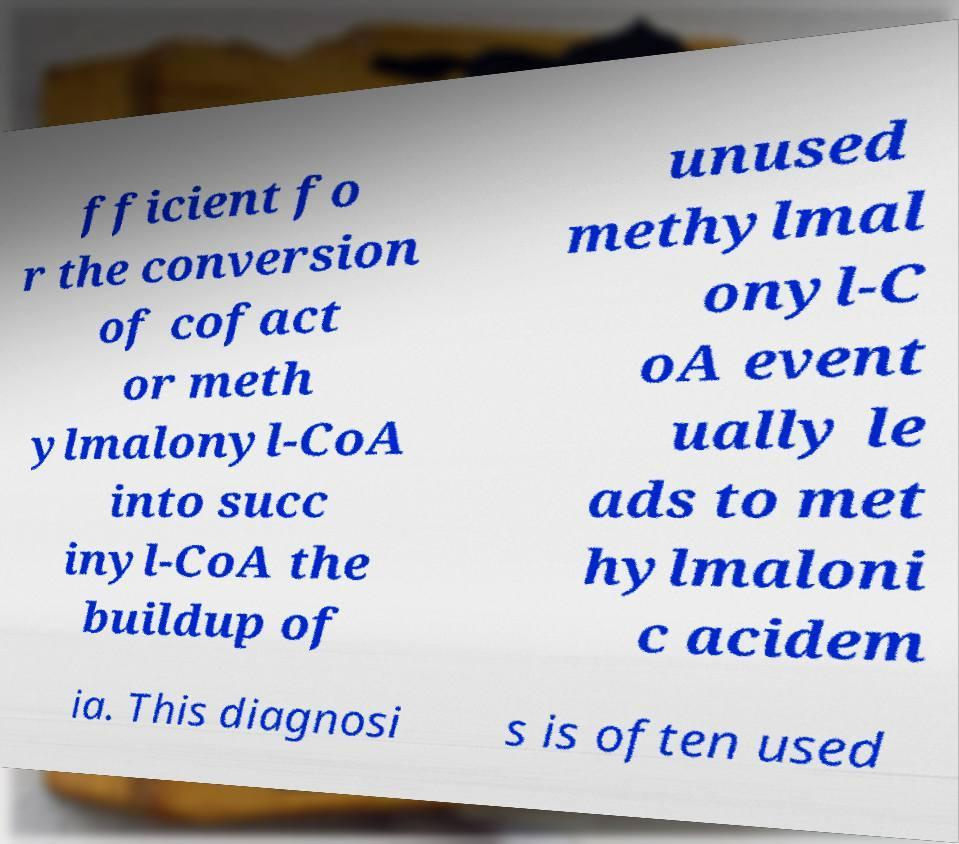For documentation purposes, I need the text within this image transcribed. Could you provide that? fficient fo r the conversion of cofact or meth ylmalonyl-CoA into succ inyl-CoA the buildup of unused methylmal onyl-C oA event ually le ads to met hylmaloni c acidem ia. This diagnosi s is often used 